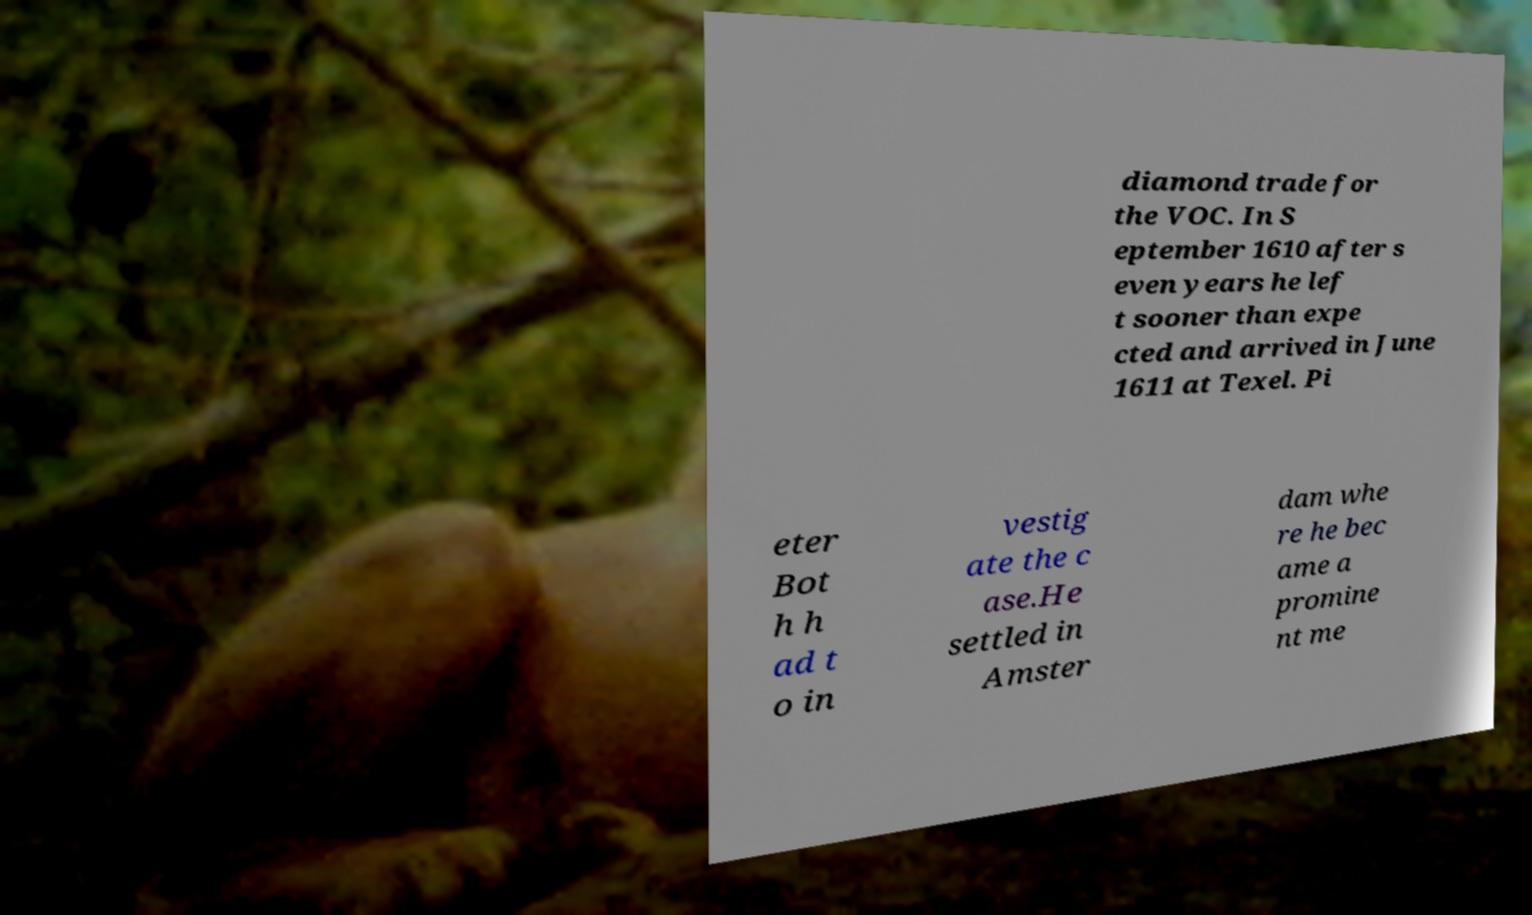Could you assist in decoding the text presented in this image and type it out clearly? diamond trade for the VOC. In S eptember 1610 after s even years he lef t sooner than expe cted and arrived in June 1611 at Texel. Pi eter Bot h h ad t o in vestig ate the c ase.He settled in Amster dam whe re he bec ame a promine nt me 